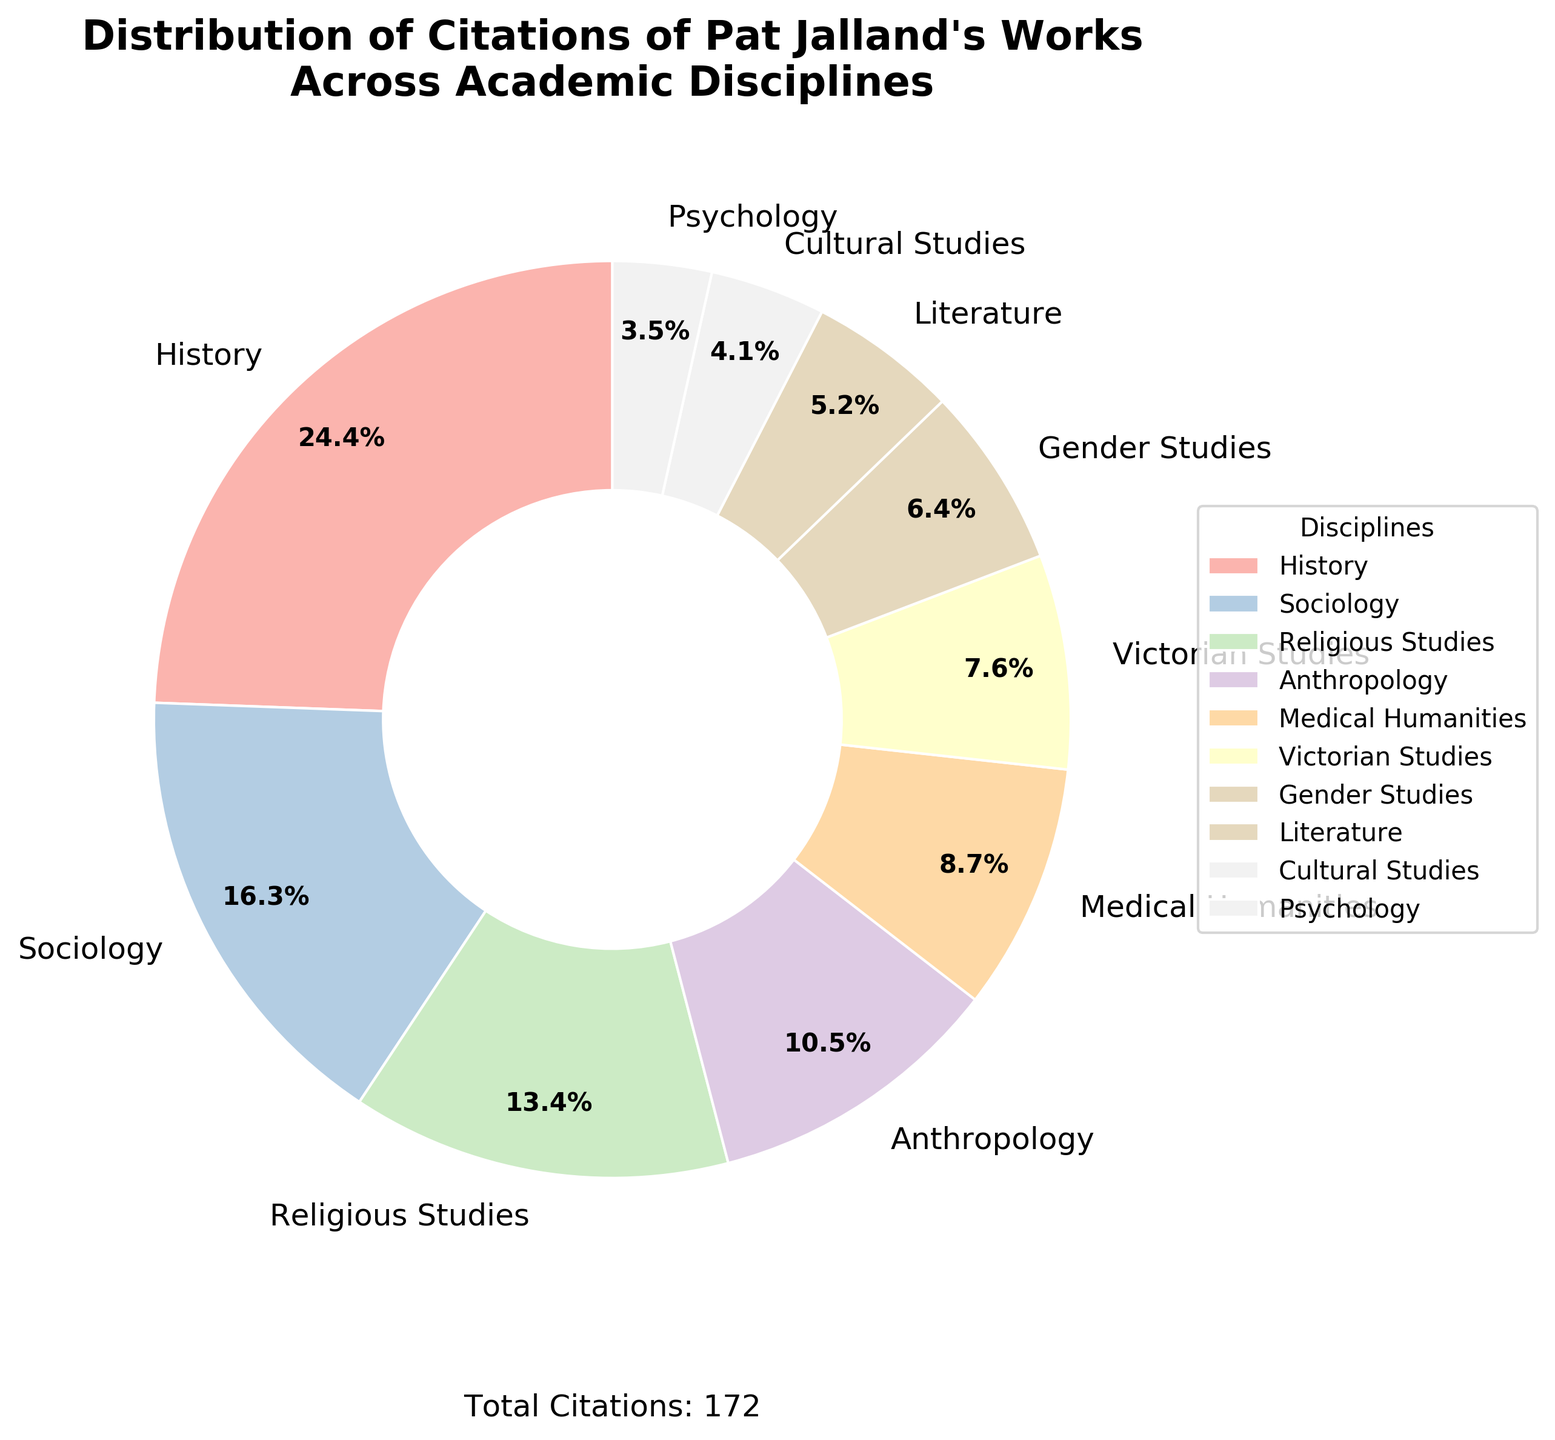Which discipline has the highest number of citations? Scan the chart and identify the segment with the largest percentage. The History segment is the largest, indicating the highest number of citations.
Answer: History What percentage of citations come from Religious Studies? Locate the Religious Studies segment and read the percentage label. The pie chart shows 15.8% for Religious Studies.
Answer: 15.8% How many more citations does History have compared to Psychology? History has 42 citations and Psychology has 6 citations. Subtract the number of Psychology citations from the number of History citations (42 - 6 = 36).
Answer: 36 Which two disciplines combined contribute to over 50% of the citations? Identify the segments with percentages next to each and check combinations. History (28.2%) and Sociology (18.8%) combined total 47%. History and Religious Studies combined total 44%. No two disciplines together exceed 50%, but History and Sociology combined are closest.
Answer: None What is the total number of citations indicated on the figure? Check the text added below the chart, which states the total number of citations. The figure mentions "Total Citations: 172".
Answer: 172 What is the smallest discipline by citation count? Look at the smallest segment in the pie chart, which is Psychology.
Answer: Psychology How many disciplines have citation percentages in the range of 10% to 20%? Count the segments with percentages within the range. Sociology (18.9%), Religious Studies (15.8%), and Anthropology (10.5%) fit within this range.
Answer: 3 Which visual attribute helps in understanding the proportion of each discipline's citations? Examine the pie chart's elements, noting that the size of each wedge (segment) visually represents proportion.
Answer: Size of each wedge How does the percentage of citations in Gender Studies compare to Victorian Studies? Locate the segments for both disciplines. Gender Studies has 6.4%, while Victorian Studies has 7.6%.
Answer: Less What is the combined percentage of citations for Literature and Cultural Studies? Sum the percentages for Literature (5.2%) and Cultural Studies (4.1%) as shown in their respective segments. (5.2% + 4.1% = 9.3%)
Answer: 9.3% 